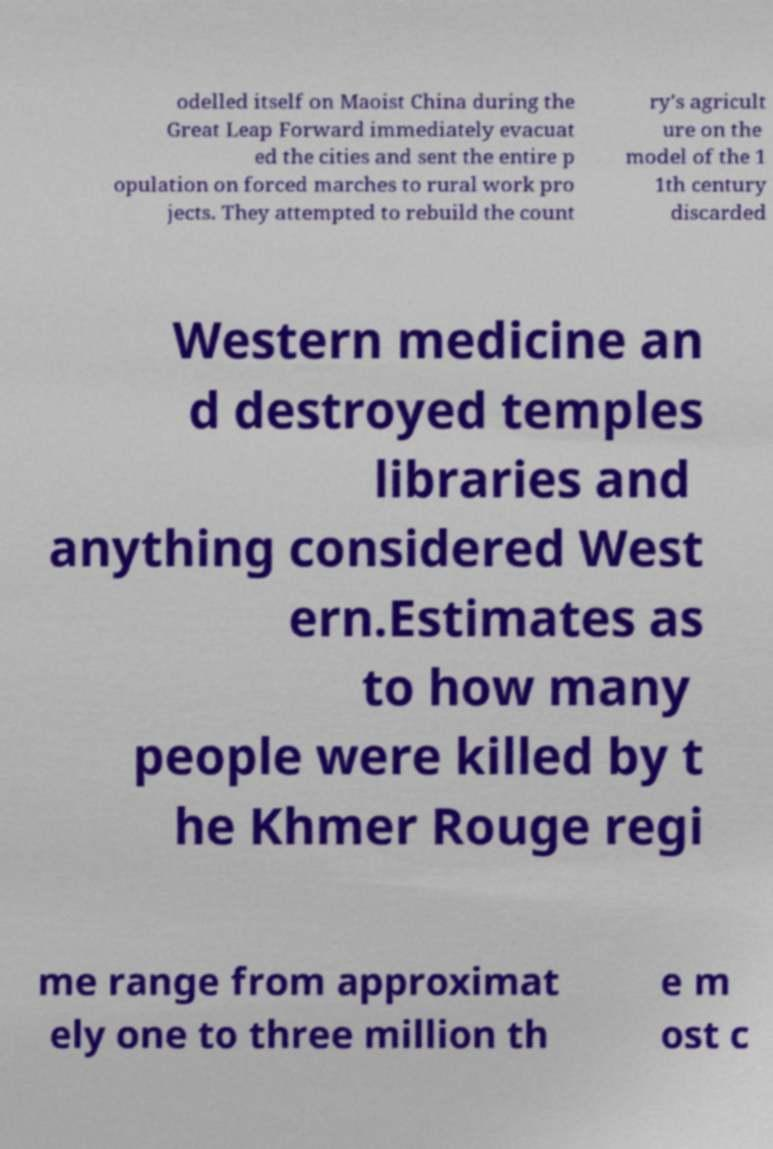Please identify and transcribe the text found in this image. odelled itself on Maoist China during the Great Leap Forward immediately evacuat ed the cities and sent the entire p opulation on forced marches to rural work pro jects. They attempted to rebuild the count ry's agricult ure on the model of the 1 1th century discarded Western medicine an d destroyed temples libraries and anything considered West ern.Estimates as to how many people were killed by t he Khmer Rouge regi me range from approximat ely one to three million th e m ost c 